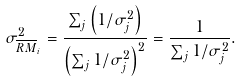<formula> <loc_0><loc_0><loc_500><loc_500>\sigma ^ { 2 } _ { \overline { R M } _ { i } } = \frac { \sum _ { j } \left ( { 1 } / { \sigma ^ { 2 } _ { j } } \right ) } { \left ( \sum _ { j } { 1 } / { \sigma _ { j } ^ { 2 } } \right ) ^ { 2 } } = \frac { 1 } { \sum _ { j } { 1 } / { \sigma _ { j } ^ { 2 } } } .</formula> 